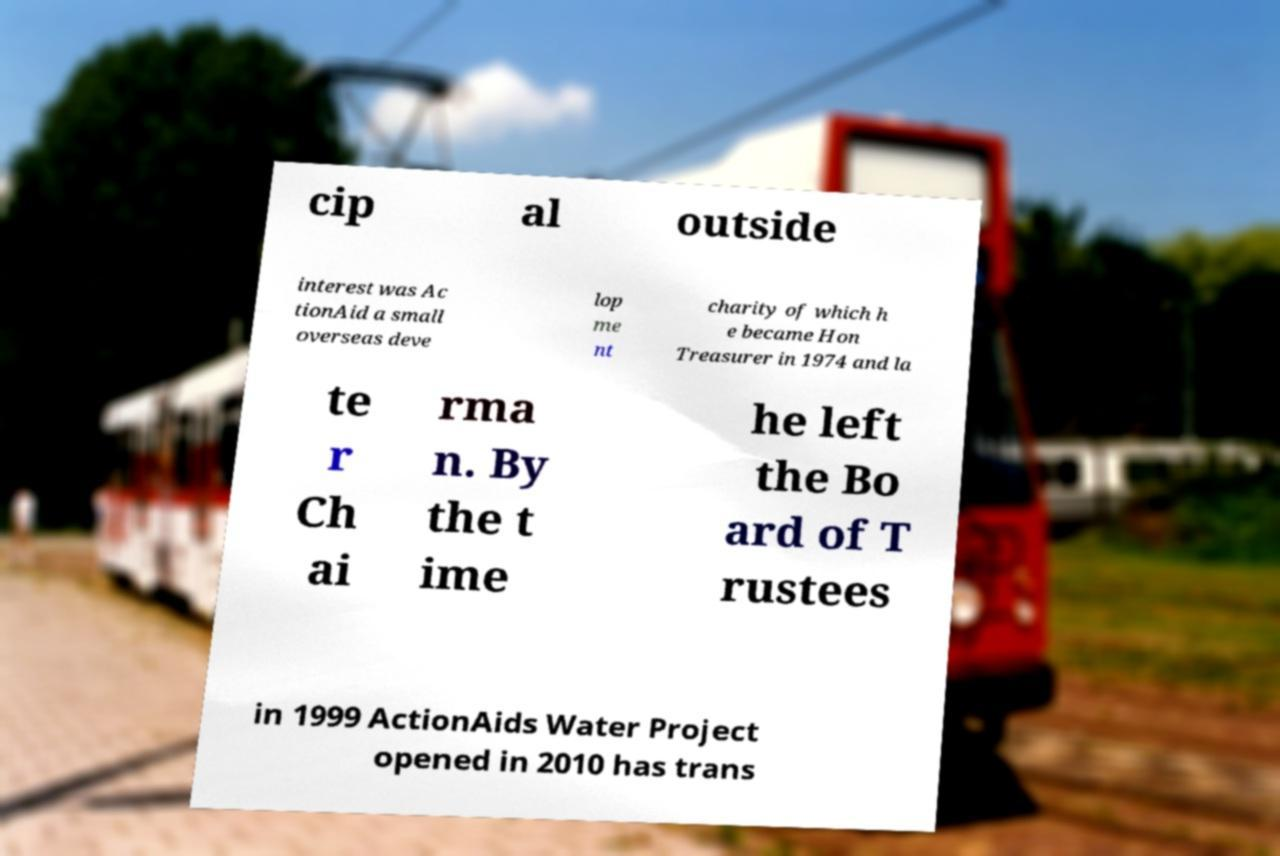Please read and relay the text visible in this image. What does it say? cip al outside interest was Ac tionAid a small overseas deve lop me nt charity of which h e became Hon Treasurer in 1974 and la te r Ch ai rma n. By the t ime he left the Bo ard of T rustees in 1999 ActionAids Water Project opened in 2010 has trans 